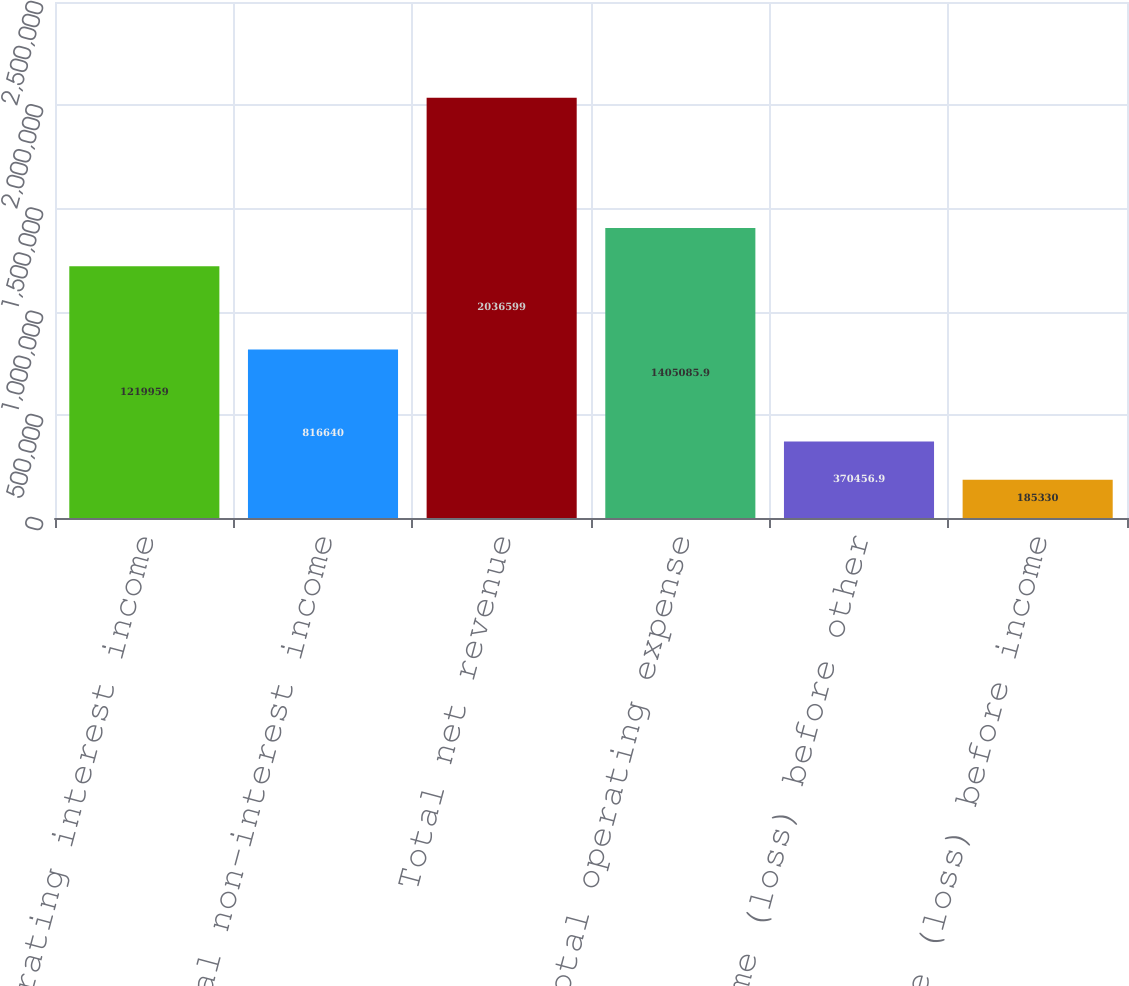Convert chart. <chart><loc_0><loc_0><loc_500><loc_500><bar_chart><fcel>Net operating interest income<fcel>Total non-interest income<fcel>Total net revenue<fcel>Total operating expense<fcel>Income (loss) before other<fcel>Income (loss) before income<nl><fcel>1.21996e+06<fcel>816640<fcel>2.0366e+06<fcel>1.40509e+06<fcel>370457<fcel>185330<nl></chart> 